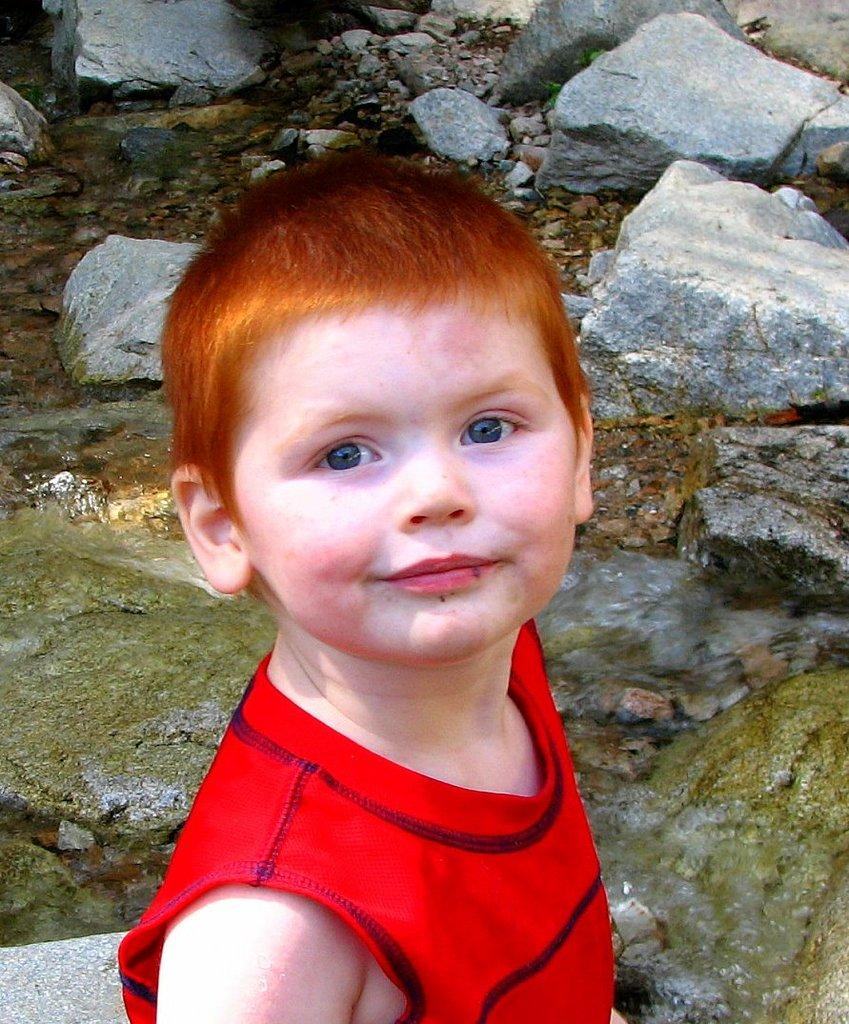What is the main subject of the image? The main subject of the image is a kid. What can be seen in the background of the image? There are stones visible in the background of the image. What book is the kid reading in the image? There is no book or reading activity visible in the image. Where is the kid's bed located in the image? There is no bed present in the image. What type of battle is taking place in the image? There is no battle or any indication of conflict in the image. 